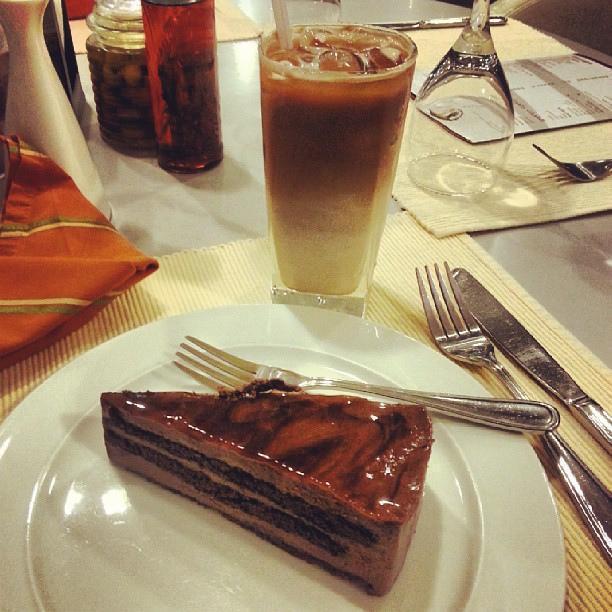What are they expecting to be poured into the upside down glass?
Pick the right solution, then justify: 'Answer: answer
Rationale: rationale.'
Options: Soda, seltzer, gatorade, wine. Answer: wine.
Rationale: Wine is expected to be poured in the upside down glass because it is a wine glass 